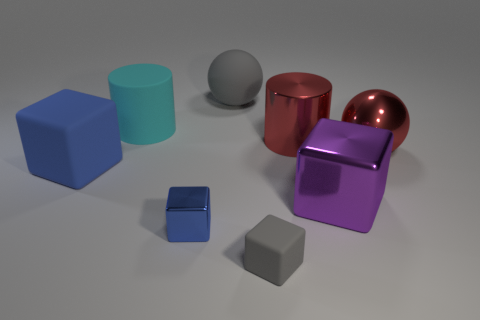What can you infer about the lighting and atmosphere of the setup? The lighting in the image suggests a soft, diffused source coming from above, as evidenced by soft shadows beneath each object. The ways in which light reflects off the metallic surfaces indicate a controlled environment, likely indoors, with an attention to highlighting the reflective quality of the shapes. The overall atmosphere appears calm and neutrally toned, which makes the colors of the objects stand out more. 